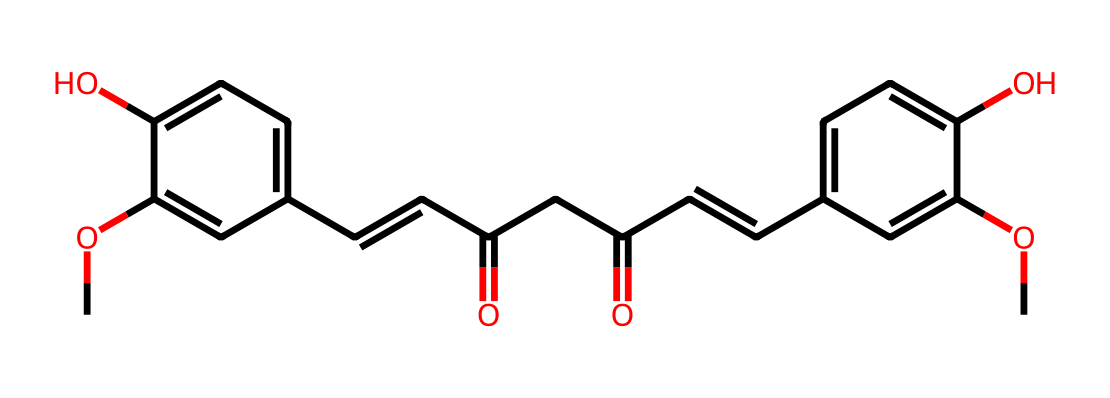What is the primary functional group present in the molecule? The molecule contains multiple hydroxyl (-OH) groups which are a characteristic feature of phenolic compounds, indicating that the primary functional group is alcohols as seen from the attached -OH groups on the aromatic rings.
Answer: hydroxyl How many carbon atoms are present in the structure? Counting the carbon atoms in the provided SMILES representation reveals there are 21 carbon atoms (C) in total within the entire molecule when considering all parts including the rings and chains.
Answer: 21 Is this molecule likely to be polar or non-polar? The presence of multiple hydroxyl groups increases polarity; thus, overall, the presence of these polar functional groups amidst the hydrophobic aromatic rings and chains leans the molecule towards being polar.
Answer: polar What type of chemical bonding is primarily present in this molecule? The molecule contains mainly covalent bonds as evidenced by the sharing of electrons among carbon, oxygen, and hydrogen atoms, which characterizes the overall bonding situation in organic compounds like this one.
Answer: covalent Which part of this chemical structure is likely responsible for its color? The conjugated double bond system in the aromatic rings plays a significant role in the absorption of visible light, which is often responsible for the vibrant color characteristic of many plant pigments including curcumin found in turmeric.
Answer: conjugated double bonds 